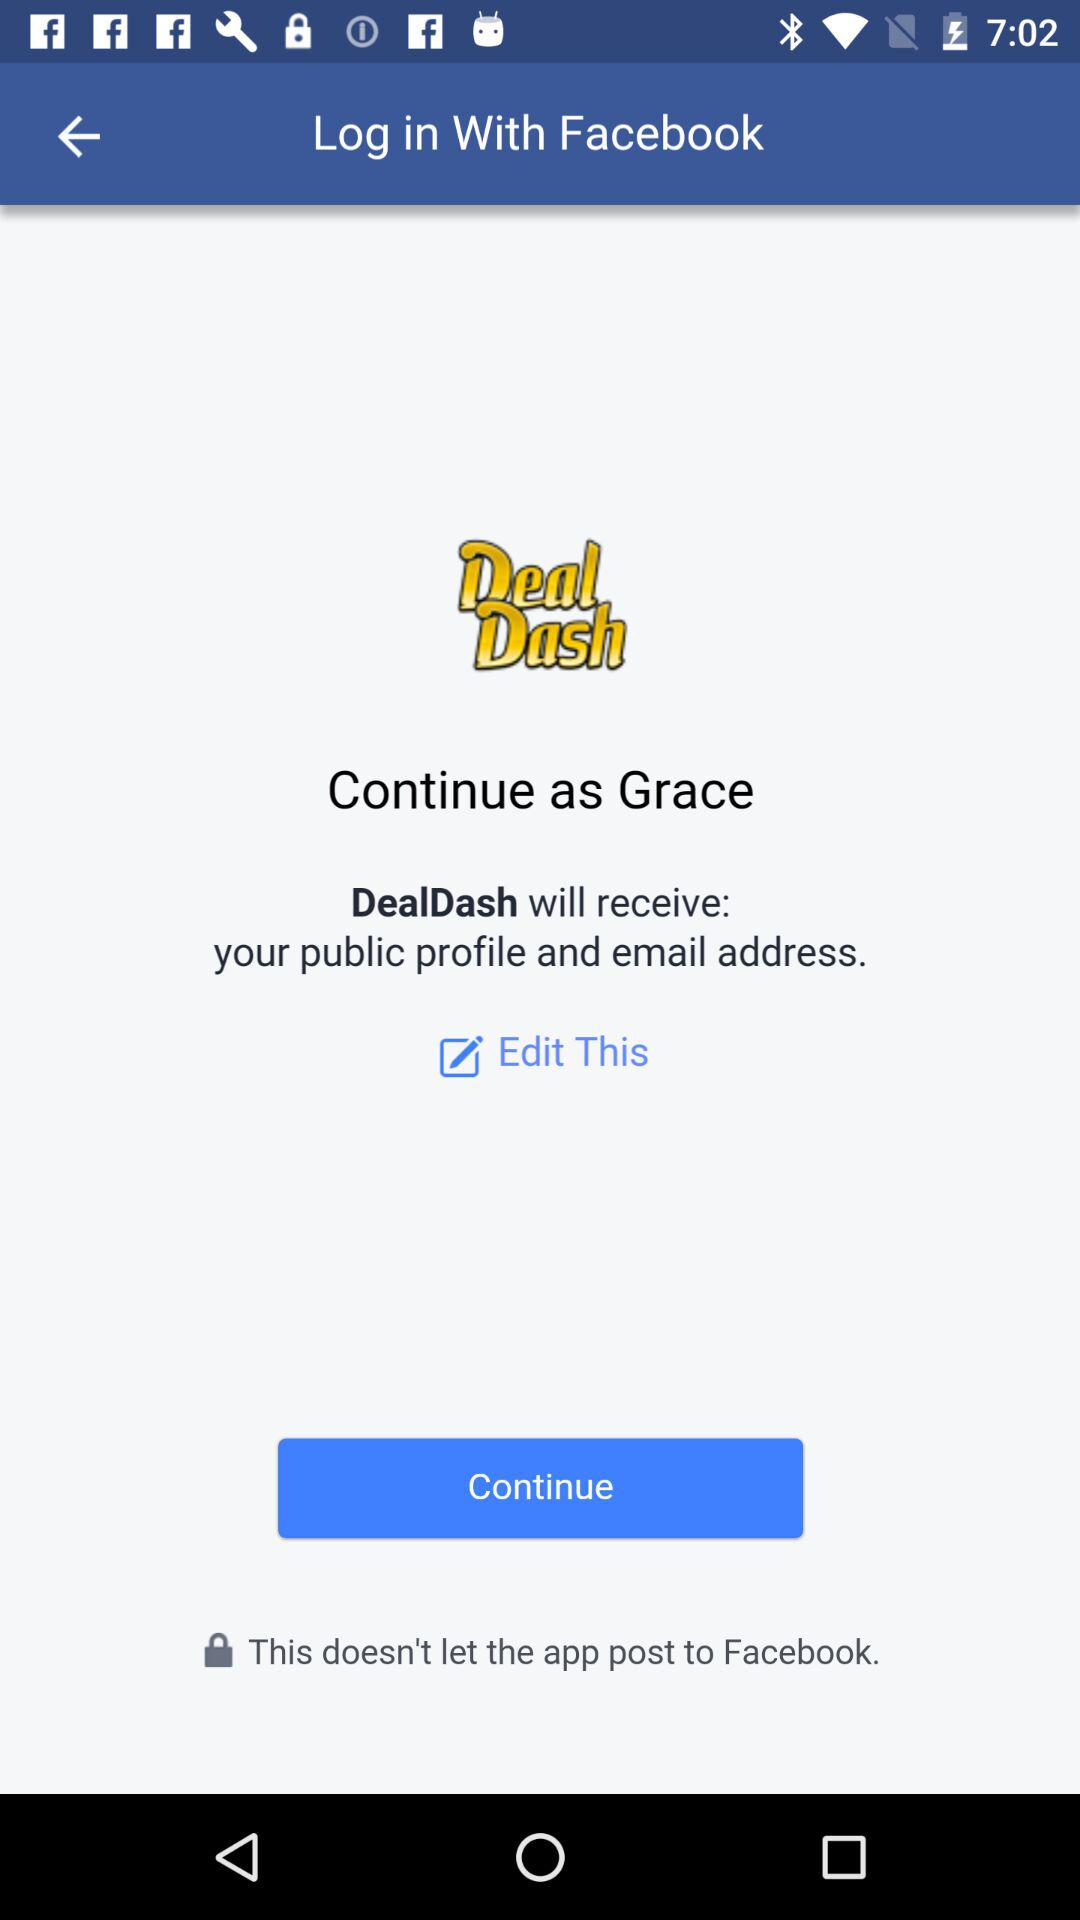When was the last time "Grace" logged in?
When the provided information is insufficient, respond with <no answer>. <no answer> 